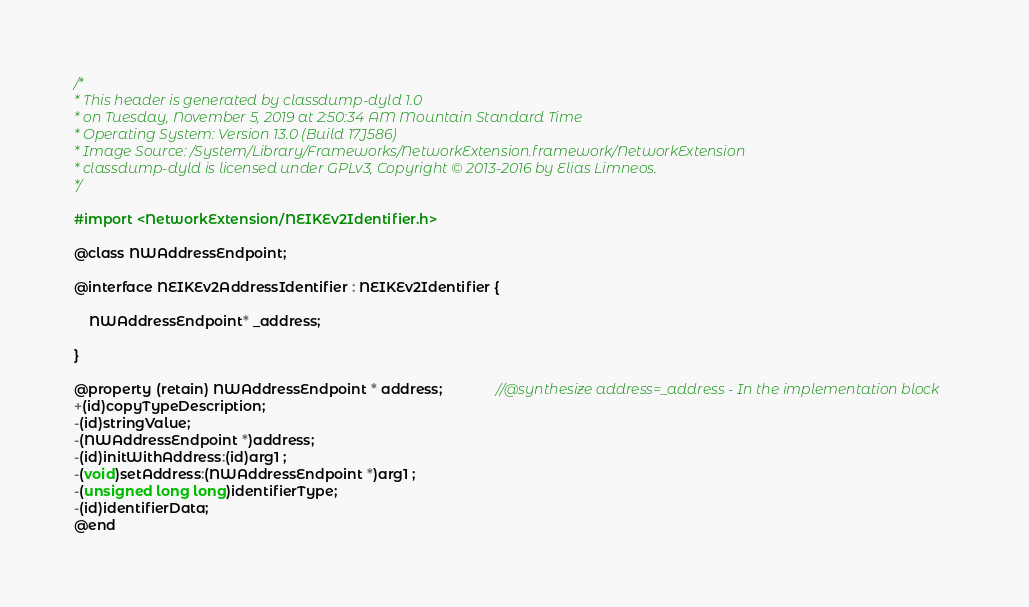<code> <loc_0><loc_0><loc_500><loc_500><_C_>/*
* This header is generated by classdump-dyld 1.0
* on Tuesday, November 5, 2019 at 2:50:34 AM Mountain Standard Time
* Operating System: Version 13.0 (Build 17J586)
* Image Source: /System/Library/Frameworks/NetworkExtension.framework/NetworkExtension
* classdump-dyld is licensed under GPLv3, Copyright © 2013-2016 by Elias Limneos.
*/

#import <NetworkExtension/NEIKEv2Identifier.h>

@class NWAddressEndpoint;

@interface NEIKEv2AddressIdentifier : NEIKEv2Identifier {

	NWAddressEndpoint* _address;

}

@property (retain) NWAddressEndpoint * address;              //@synthesize address=_address - In the implementation block
+(id)copyTypeDescription;
-(id)stringValue;
-(NWAddressEndpoint *)address;
-(id)initWithAddress:(id)arg1 ;
-(void)setAddress:(NWAddressEndpoint *)arg1 ;
-(unsigned long long)identifierType;
-(id)identifierData;
@end

</code> 